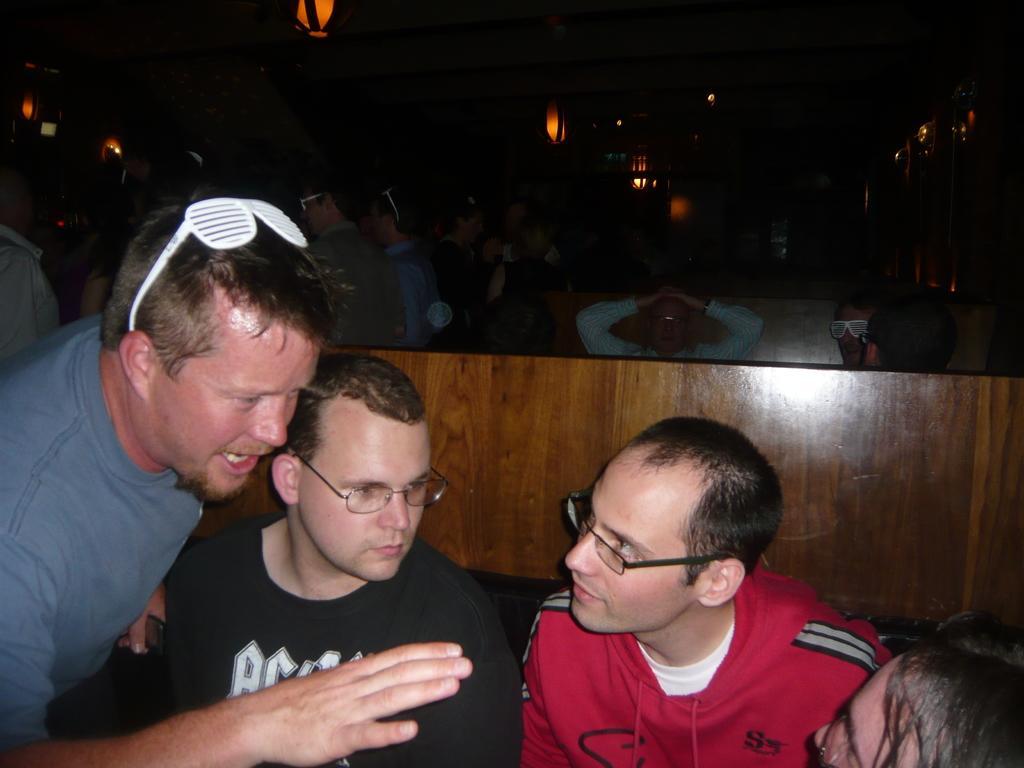How would you summarize this image in a sentence or two? In this image I can see group of people. In front the person is wearing white and red color dress. In the background I can see few lights. 